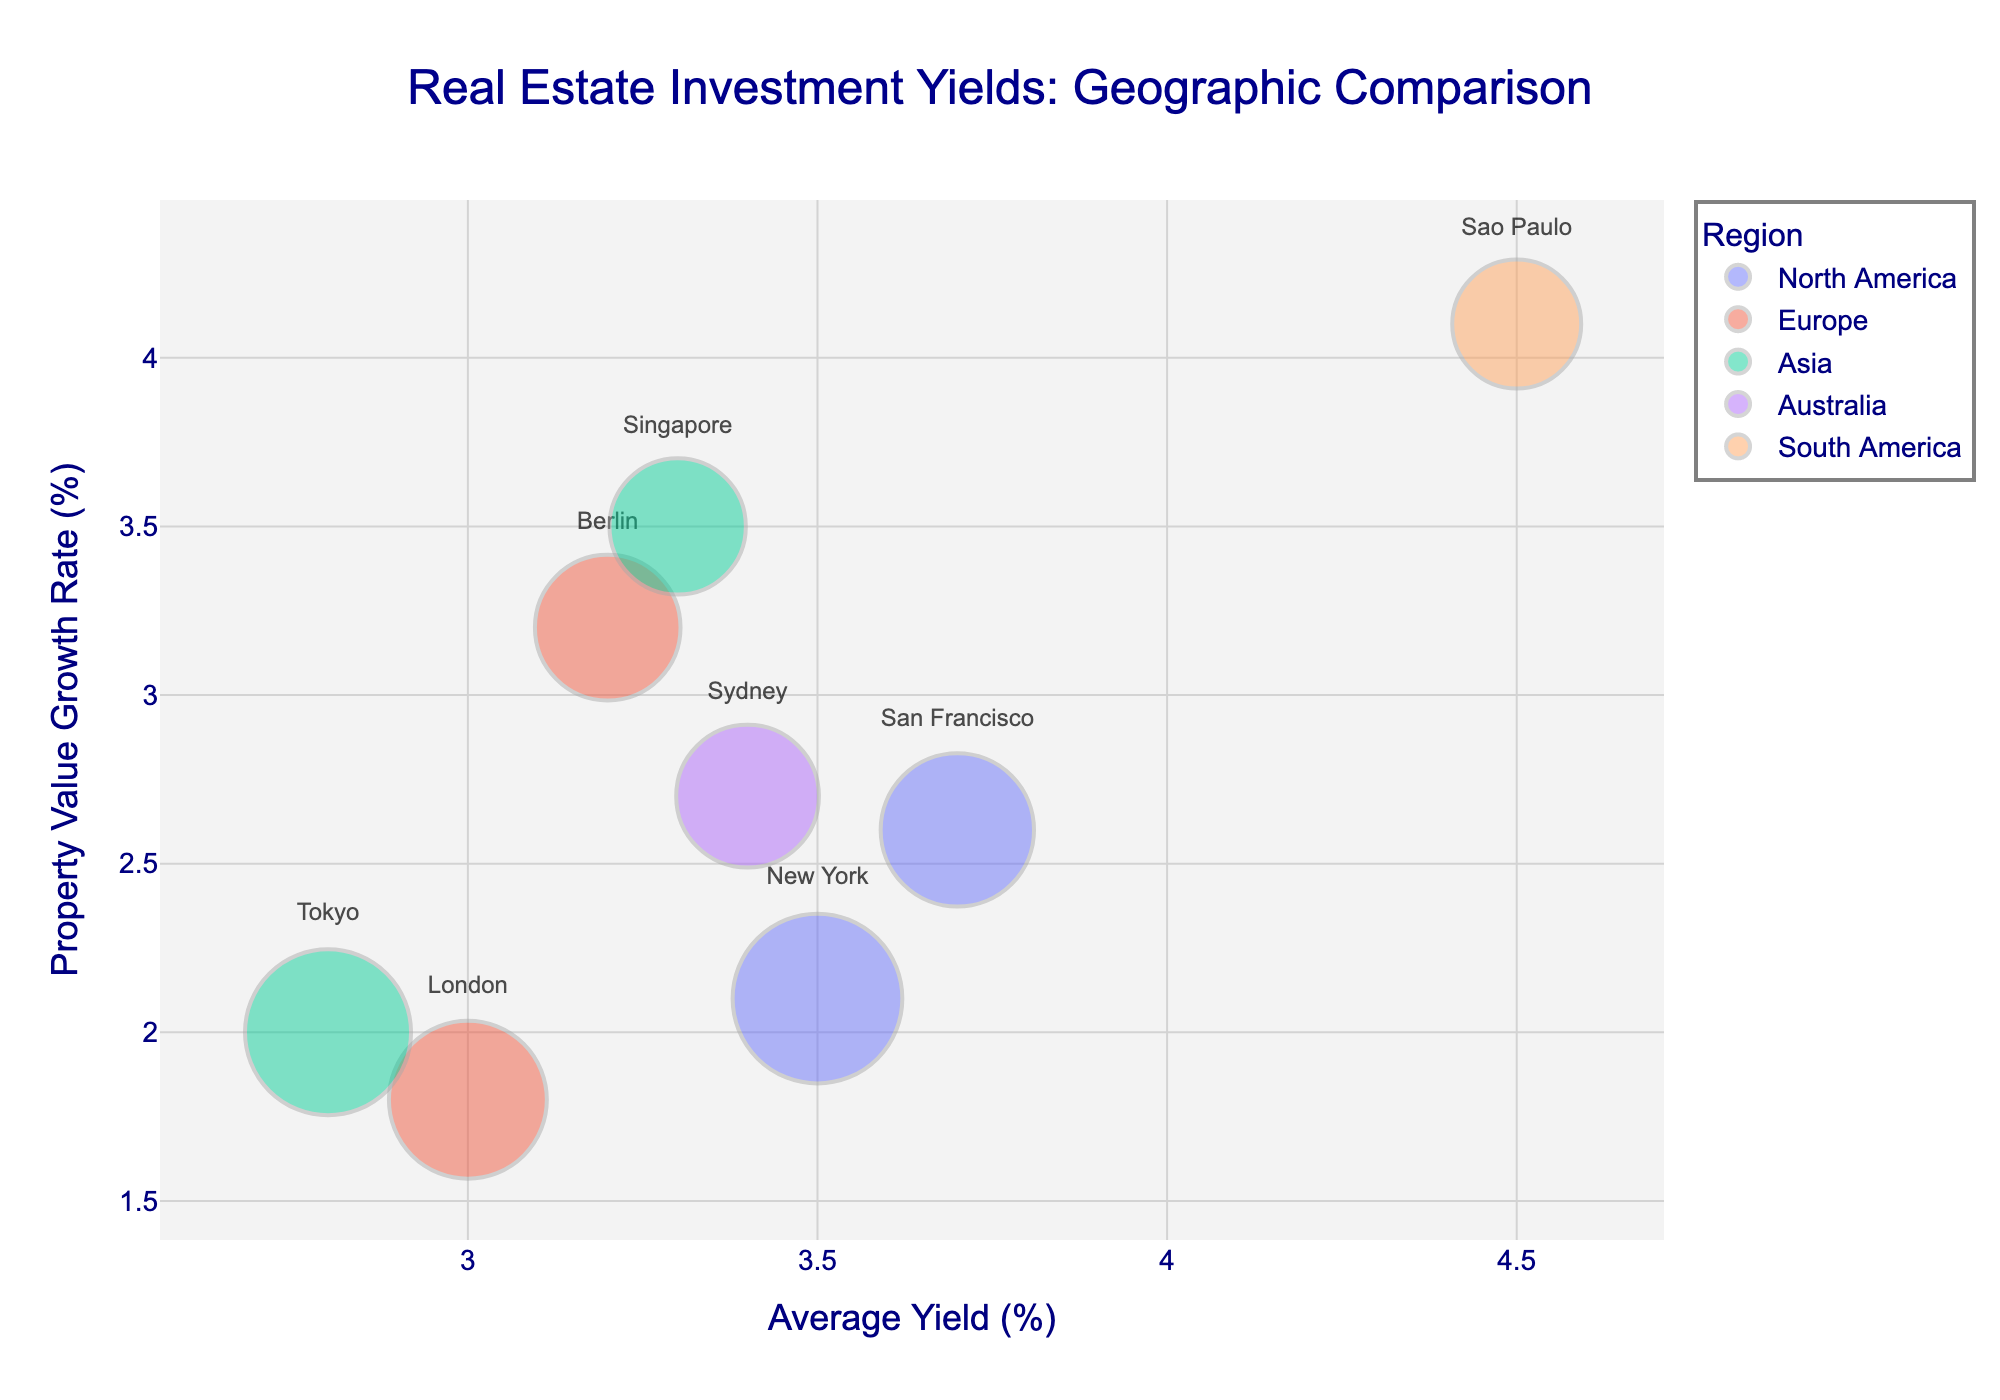what is the title of the figure? The title of the figure is usually displayed at the top of the chart. This one is "Real Estate Investment Yields: Geographic Comparison"
Answer: Real Estate Investment Yields: Geographic Comparison How many bubbles are displayed on the chart? Each bubble represents a city. Counting the bubbles on the chart gives us this total.
Answer: 8 Which region has the city with the highest property value growth rate? To find this, one must look at the y-axis for the highest value in "Property Value Growth Rate (%)" and check its corresponding bubble's color and city label. Sao Paulo has the highest growth rate at 4.1%, belonging to South America.
Answer: South America Which city in North America has a higher average yield? Look at the "Average Yield (%)" values for New York and San Francisco on the x-axis and compare them. San Francisco has an average yield of 3.7%, while New York has 3.5%.
Answer: San Francisco Identify the city with the largest market size. Bubble size indicates market size. The largest bubble represents the city with the largest market size. New York has the largest bubble with a market size of $1200B.
Answer: New York Which city in Europe has a higher property value growth rate? Compare the "Property Value Growth Rate (%)" values for London and Berlin on the y-axis. Berlin's growth rate is 3.2% while London's is 1.8%.
Answer: Berlin Which city has the smallest market size? The smallest bubble represents the city with the smallest market size; hovering over the smallest bubble indicates it's Sao Paulo with $400B.
Answer: Sao Paulo Which region contains cities with average yields greater than 3.4%? Examine the x-axis for cities with "Average Yield (%)" greater than 3.4% and identify their regions: São Paulo (South America), Sydney (Australia), San Francisco (North America), and Singapore (Asia).
Answer: South America, Australia, North America, Asia What is the average property value growth rate for cities in the Asia region? Identify cities in the Asia region (Tokyo and Singapore), sum their growth rates (2.0% + 3.5%), and divide by the number of cities, 2. (2.0 + 3.5) / 2 = 2.75%.
Answer: 2.75% Which city has a similar average yield to Sydney? Find the x-axis position of Sydney's "Average Yield (%)" (3.4%) and look for other cities close to this value. Berlin (3.2%) and New York (3.5%) are close.
Answer: Berlin, New York 